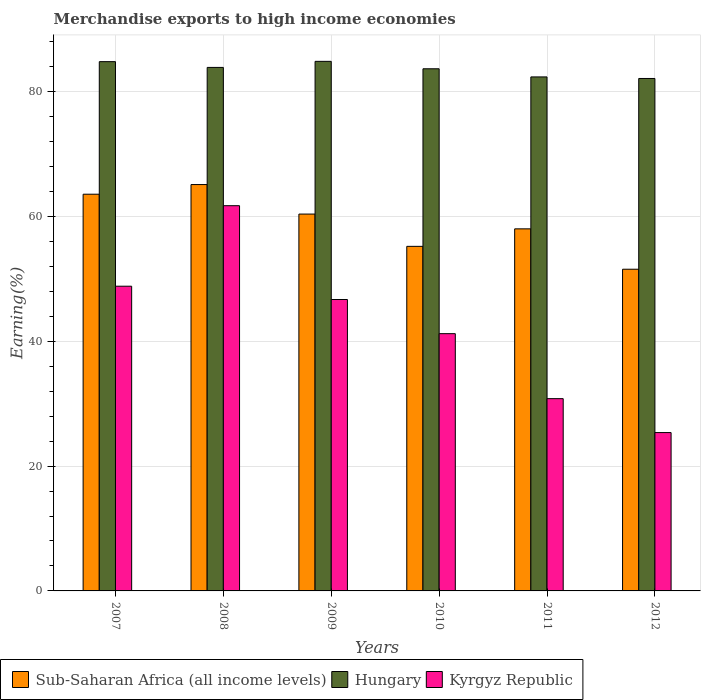How many different coloured bars are there?
Provide a short and direct response. 3. Are the number of bars on each tick of the X-axis equal?
Offer a very short reply. Yes. What is the percentage of amount earned from merchandise exports in Hungary in 2010?
Make the answer very short. 83.67. Across all years, what is the maximum percentage of amount earned from merchandise exports in Hungary?
Your response must be concise. 84.86. Across all years, what is the minimum percentage of amount earned from merchandise exports in Sub-Saharan Africa (all income levels)?
Your response must be concise. 51.55. What is the total percentage of amount earned from merchandise exports in Kyrgyz Republic in the graph?
Offer a very short reply. 254.66. What is the difference between the percentage of amount earned from merchandise exports in Kyrgyz Republic in 2008 and that in 2010?
Your response must be concise. 20.51. What is the difference between the percentage of amount earned from merchandise exports in Kyrgyz Republic in 2010 and the percentage of amount earned from merchandise exports in Hungary in 2009?
Your answer should be very brief. -43.64. What is the average percentage of amount earned from merchandise exports in Sub-Saharan Africa (all income levels) per year?
Ensure brevity in your answer.  58.98. In the year 2012, what is the difference between the percentage of amount earned from merchandise exports in Kyrgyz Republic and percentage of amount earned from merchandise exports in Sub-Saharan Africa (all income levels)?
Offer a very short reply. -26.18. What is the ratio of the percentage of amount earned from merchandise exports in Hungary in 2008 to that in 2011?
Provide a short and direct response. 1.02. Is the percentage of amount earned from merchandise exports in Sub-Saharan Africa (all income levels) in 2008 less than that in 2012?
Provide a short and direct response. No. What is the difference between the highest and the second highest percentage of amount earned from merchandise exports in Sub-Saharan Africa (all income levels)?
Keep it short and to the point. 1.55. What is the difference between the highest and the lowest percentage of amount earned from merchandise exports in Sub-Saharan Africa (all income levels)?
Your answer should be very brief. 13.57. In how many years, is the percentage of amount earned from merchandise exports in Hungary greater than the average percentage of amount earned from merchandise exports in Hungary taken over all years?
Keep it short and to the point. 4. What does the 1st bar from the left in 2008 represents?
Ensure brevity in your answer.  Sub-Saharan Africa (all income levels). What does the 2nd bar from the right in 2012 represents?
Provide a succinct answer. Hungary. What is the difference between two consecutive major ticks on the Y-axis?
Offer a very short reply. 20. Are the values on the major ticks of Y-axis written in scientific E-notation?
Your response must be concise. No. Where does the legend appear in the graph?
Your answer should be very brief. Bottom left. How are the legend labels stacked?
Offer a very short reply. Horizontal. What is the title of the graph?
Give a very brief answer. Merchandise exports to high income economies. Does "Suriname" appear as one of the legend labels in the graph?
Provide a succinct answer. No. What is the label or title of the Y-axis?
Your response must be concise. Earning(%). What is the Earning(%) of Sub-Saharan Africa (all income levels) in 2007?
Ensure brevity in your answer.  63.57. What is the Earning(%) of Hungary in 2007?
Make the answer very short. 84.81. What is the Earning(%) of Kyrgyz Republic in 2007?
Offer a very short reply. 48.83. What is the Earning(%) in Sub-Saharan Africa (all income levels) in 2008?
Offer a very short reply. 65.12. What is the Earning(%) in Hungary in 2008?
Provide a short and direct response. 83.89. What is the Earning(%) in Kyrgyz Republic in 2008?
Your answer should be very brief. 61.73. What is the Earning(%) of Sub-Saharan Africa (all income levels) in 2009?
Make the answer very short. 60.39. What is the Earning(%) of Hungary in 2009?
Keep it short and to the point. 84.86. What is the Earning(%) in Kyrgyz Republic in 2009?
Your answer should be compact. 46.7. What is the Earning(%) of Sub-Saharan Africa (all income levels) in 2010?
Give a very brief answer. 55.21. What is the Earning(%) in Hungary in 2010?
Give a very brief answer. 83.67. What is the Earning(%) of Kyrgyz Republic in 2010?
Your answer should be compact. 41.22. What is the Earning(%) of Sub-Saharan Africa (all income levels) in 2011?
Make the answer very short. 58.02. What is the Earning(%) in Hungary in 2011?
Keep it short and to the point. 82.36. What is the Earning(%) in Kyrgyz Republic in 2011?
Your response must be concise. 30.81. What is the Earning(%) in Sub-Saharan Africa (all income levels) in 2012?
Ensure brevity in your answer.  51.55. What is the Earning(%) in Hungary in 2012?
Your response must be concise. 82.12. What is the Earning(%) in Kyrgyz Republic in 2012?
Keep it short and to the point. 25.37. Across all years, what is the maximum Earning(%) in Sub-Saharan Africa (all income levels)?
Your answer should be very brief. 65.12. Across all years, what is the maximum Earning(%) of Hungary?
Provide a succinct answer. 84.86. Across all years, what is the maximum Earning(%) in Kyrgyz Republic?
Provide a short and direct response. 61.73. Across all years, what is the minimum Earning(%) of Sub-Saharan Africa (all income levels)?
Keep it short and to the point. 51.55. Across all years, what is the minimum Earning(%) in Hungary?
Give a very brief answer. 82.12. Across all years, what is the minimum Earning(%) in Kyrgyz Republic?
Your answer should be very brief. 25.37. What is the total Earning(%) in Sub-Saharan Africa (all income levels) in the graph?
Give a very brief answer. 353.86. What is the total Earning(%) of Hungary in the graph?
Keep it short and to the point. 501.7. What is the total Earning(%) in Kyrgyz Republic in the graph?
Provide a short and direct response. 254.66. What is the difference between the Earning(%) of Sub-Saharan Africa (all income levels) in 2007 and that in 2008?
Provide a succinct answer. -1.55. What is the difference between the Earning(%) in Hungary in 2007 and that in 2008?
Your response must be concise. 0.93. What is the difference between the Earning(%) in Kyrgyz Republic in 2007 and that in 2008?
Your answer should be compact. -12.9. What is the difference between the Earning(%) of Sub-Saharan Africa (all income levels) in 2007 and that in 2009?
Your answer should be compact. 3.18. What is the difference between the Earning(%) in Hungary in 2007 and that in 2009?
Offer a terse response. -0.05. What is the difference between the Earning(%) of Kyrgyz Republic in 2007 and that in 2009?
Your answer should be compact. 2.13. What is the difference between the Earning(%) in Sub-Saharan Africa (all income levels) in 2007 and that in 2010?
Your answer should be compact. 8.36. What is the difference between the Earning(%) of Hungary in 2007 and that in 2010?
Your answer should be compact. 1.14. What is the difference between the Earning(%) in Kyrgyz Republic in 2007 and that in 2010?
Offer a terse response. 7.6. What is the difference between the Earning(%) in Sub-Saharan Africa (all income levels) in 2007 and that in 2011?
Provide a succinct answer. 5.55. What is the difference between the Earning(%) in Hungary in 2007 and that in 2011?
Keep it short and to the point. 2.45. What is the difference between the Earning(%) in Kyrgyz Republic in 2007 and that in 2011?
Offer a terse response. 18.02. What is the difference between the Earning(%) in Sub-Saharan Africa (all income levels) in 2007 and that in 2012?
Provide a short and direct response. 12.02. What is the difference between the Earning(%) of Hungary in 2007 and that in 2012?
Make the answer very short. 2.7. What is the difference between the Earning(%) in Kyrgyz Republic in 2007 and that in 2012?
Provide a succinct answer. 23.45. What is the difference between the Earning(%) of Sub-Saharan Africa (all income levels) in 2008 and that in 2009?
Offer a terse response. 4.73. What is the difference between the Earning(%) of Hungary in 2008 and that in 2009?
Provide a short and direct response. -0.97. What is the difference between the Earning(%) of Kyrgyz Republic in 2008 and that in 2009?
Make the answer very short. 15.03. What is the difference between the Earning(%) of Sub-Saharan Africa (all income levels) in 2008 and that in 2010?
Your answer should be very brief. 9.9. What is the difference between the Earning(%) in Hungary in 2008 and that in 2010?
Offer a terse response. 0.22. What is the difference between the Earning(%) in Kyrgyz Republic in 2008 and that in 2010?
Offer a terse response. 20.51. What is the difference between the Earning(%) of Sub-Saharan Africa (all income levels) in 2008 and that in 2011?
Your answer should be very brief. 7.1. What is the difference between the Earning(%) of Hungary in 2008 and that in 2011?
Your answer should be very brief. 1.52. What is the difference between the Earning(%) of Kyrgyz Republic in 2008 and that in 2011?
Your answer should be very brief. 30.92. What is the difference between the Earning(%) in Sub-Saharan Africa (all income levels) in 2008 and that in 2012?
Give a very brief answer. 13.57. What is the difference between the Earning(%) of Hungary in 2008 and that in 2012?
Provide a short and direct response. 1.77. What is the difference between the Earning(%) in Kyrgyz Republic in 2008 and that in 2012?
Keep it short and to the point. 36.35. What is the difference between the Earning(%) in Sub-Saharan Africa (all income levels) in 2009 and that in 2010?
Provide a succinct answer. 5.17. What is the difference between the Earning(%) of Hungary in 2009 and that in 2010?
Offer a very short reply. 1.19. What is the difference between the Earning(%) in Kyrgyz Republic in 2009 and that in 2010?
Ensure brevity in your answer.  5.47. What is the difference between the Earning(%) of Sub-Saharan Africa (all income levels) in 2009 and that in 2011?
Offer a terse response. 2.37. What is the difference between the Earning(%) of Hungary in 2009 and that in 2011?
Give a very brief answer. 2.49. What is the difference between the Earning(%) of Kyrgyz Republic in 2009 and that in 2011?
Keep it short and to the point. 15.89. What is the difference between the Earning(%) of Sub-Saharan Africa (all income levels) in 2009 and that in 2012?
Offer a very short reply. 8.84. What is the difference between the Earning(%) in Hungary in 2009 and that in 2012?
Your answer should be compact. 2.74. What is the difference between the Earning(%) in Kyrgyz Republic in 2009 and that in 2012?
Give a very brief answer. 21.32. What is the difference between the Earning(%) in Sub-Saharan Africa (all income levels) in 2010 and that in 2011?
Keep it short and to the point. -2.81. What is the difference between the Earning(%) of Hungary in 2010 and that in 2011?
Make the answer very short. 1.3. What is the difference between the Earning(%) of Kyrgyz Republic in 2010 and that in 2011?
Give a very brief answer. 10.41. What is the difference between the Earning(%) in Sub-Saharan Africa (all income levels) in 2010 and that in 2012?
Your answer should be very brief. 3.66. What is the difference between the Earning(%) of Hungary in 2010 and that in 2012?
Give a very brief answer. 1.55. What is the difference between the Earning(%) in Kyrgyz Republic in 2010 and that in 2012?
Offer a terse response. 15.85. What is the difference between the Earning(%) of Sub-Saharan Africa (all income levels) in 2011 and that in 2012?
Offer a terse response. 6.47. What is the difference between the Earning(%) in Hungary in 2011 and that in 2012?
Your answer should be compact. 0.25. What is the difference between the Earning(%) in Kyrgyz Republic in 2011 and that in 2012?
Offer a very short reply. 5.44. What is the difference between the Earning(%) in Sub-Saharan Africa (all income levels) in 2007 and the Earning(%) in Hungary in 2008?
Offer a terse response. -20.32. What is the difference between the Earning(%) of Sub-Saharan Africa (all income levels) in 2007 and the Earning(%) of Kyrgyz Republic in 2008?
Provide a succinct answer. 1.84. What is the difference between the Earning(%) in Hungary in 2007 and the Earning(%) in Kyrgyz Republic in 2008?
Offer a terse response. 23.08. What is the difference between the Earning(%) of Sub-Saharan Africa (all income levels) in 2007 and the Earning(%) of Hungary in 2009?
Provide a succinct answer. -21.29. What is the difference between the Earning(%) of Sub-Saharan Africa (all income levels) in 2007 and the Earning(%) of Kyrgyz Republic in 2009?
Offer a terse response. 16.87. What is the difference between the Earning(%) in Hungary in 2007 and the Earning(%) in Kyrgyz Republic in 2009?
Ensure brevity in your answer.  38.12. What is the difference between the Earning(%) in Sub-Saharan Africa (all income levels) in 2007 and the Earning(%) in Hungary in 2010?
Provide a succinct answer. -20.1. What is the difference between the Earning(%) of Sub-Saharan Africa (all income levels) in 2007 and the Earning(%) of Kyrgyz Republic in 2010?
Offer a terse response. 22.35. What is the difference between the Earning(%) of Hungary in 2007 and the Earning(%) of Kyrgyz Republic in 2010?
Provide a succinct answer. 43.59. What is the difference between the Earning(%) of Sub-Saharan Africa (all income levels) in 2007 and the Earning(%) of Hungary in 2011?
Your answer should be very brief. -18.79. What is the difference between the Earning(%) of Sub-Saharan Africa (all income levels) in 2007 and the Earning(%) of Kyrgyz Republic in 2011?
Provide a succinct answer. 32.76. What is the difference between the Earning(%) of Hungary in 2007 and the Earning(%) of Kyrgyz Republic in 2011?
Your answer should be compact. 54. What is the difference between the Earning(%) in Sub-Saharan Africa (all income levels) in 2007 and the Earning(%) in Hungary in 2012?
Ensure brevity in your answer.  -18.55. What is the difference between the Earning(%) of Sub-Saharan Africa (all income levels) in 2007 and the Earning(%) of Kyrgyz Republic in 2012?
Provide a succinct answer. 38.2. What is the difference between the Earning(%) of Hungary in 2007 and the Earning(%) of Kyrgyz Republic in 2012?
Your response must be concise. 59.44. What is the difference between the Earning(%) in Sub-Saharan Africa (all income levels) in 2008 and the Earning(%) in Hungary in 2009?
Your answer should be very brief. -19.74. What is the difference between the Earning(%) in Sub-Saharan Africa (all income levels) in 2008 and the Earning(%) in Kyrgyz Republic in 2009?
Make the answer very short. 18.42. What is the difference between the Earning(%) in Hungary in 2008 and the Earning(%) in Kyrgyz Republic in 2009?
Provide a short and direct response. 37.19. What is the difference between the Earning(%) of Sub-Saharan Africa (all income levels) in 2008 and the Earning(%) of Hungary in 2010?
Your answer should be very brief. -18.55. What is the difference between the Earning(%) in Sub-Saharan Africa (all income levels) in 2008 and the Earning(%) in Kyrgyz Republic in 2010?
Offer a very short reply. 23.89. What is the difference between the Earning(%) in Hungary in 2008 and the Earning(%) in Kyrgyz Republic in 2010?
Offer a very short reply. 42.66. What is the difference between the Earning(%) in Sub-Saharan Africa (all income levels) in 2008 and the Earning(%) in Hungary in 2011?
Your answer should be compact. -17.25. What is the difference between the Earning(%) in Sub-Saharan Africa (all income levels) in 2008 and the Earning(%) in Kyrgyz Republic in 2011?
Ensure brevity in your answer.  34.31. What is the difference between the Earning(%) in Hungary in 2008 and the Earning(%) in Kyrgyz Republic in 2011?
Make the answer very short. 53.08. What is the difference between the Earning(%) of Sub-Saharan Africa (all income levels) in 2008 and the Earning(%) of Hungary in 2012?
Make the answer very short. -17. What is the difference between the Earning(%) of Sub-Saharan Africa (all income levels) in 2008 and the Earning(%) of Kyrgyz Republic in 2012?
Provide a short and direct response. 39.74. What is the difference between the Earning(%) of Hungary in 2008 and the Earning(%) of Kyrgyz Republic in 2012?
Your response must be concise. 58.51. What is the difference between the Earning(%) in Sub-Saharan Africa (all income levels) in 2009 and the Earning(%) in Hungary in 2010?
Offer a very short reply. -23.28. What is the difference between the Earning(%) of Sub-Saharan Africa (all income levels) in 2009 and the Earning(%) of Kyrgyz Republic in 2010?
Provide a succinct answer. 19.16. What is the difference between the Earning(%) in Hungary in 2009 and the Earning(%) in Kyrgyz Republic in 2010?
Give a very brief answer. 43.64. What is the difference between the Earning(%) in Sub-Saharan Africa (all income levels) in 2009 and the Earning(%) in Hungary in 2011?
Your response must be concise. -21.98. What is the difference between the Earning(%) of Sub-Saharan Africa (all income levels) in 2009 and the Earning(%) of Kyrgyz Republic in 2011?
Ensure brevity in your answer.  29.58. What is the difference between the Earning(%) of Hungary in 2009 and the Earning(%) of Kyrgyz Republic in 2011?
Ensure brevity in your answer.  54.05. What is the difference between the Earning(%) of Sub-Saharan Africa (all income levels) in 2009 and the Earning(%) of Hungary in 2012?
Give a very brief answer. -21.73. What is the difference between the Earning(%) of Sub-Saharan Africa (all income levels) in 2009 and the Earning(%) of Kyrgyz Republic in 2012?
Keep it short and to the point. 35.01. What is the difference between the Earning(%) of Hungary in 2009 and the Earning(%) of Kyrgyz Republic in 2012?
Keep it short and to the point. 59.48. What is the difference between the Earning(%) of Sub-Saharan Africa (all income levels) in 2010 and the Earning(%) of Hungary in 2011?
Your response must be concise. -27.15. What is the difference between the Earning(%) in Sub-Saharan Africa (all income levels) in 2010 and the Earning(%) in Kyrgyz Republic in 2011?
Your response must be concise. 24.4. What is the difference between the Earning(%) in Hungary in 2010 and the Earning(%) in Kyrgyz Republic in 2011?
Offer a very short reply. 52.86. What is the difference between the Earning(%) of Sub-Saharan Africa (all income levels) in 2010 and the Earning(%) of Hungary in 2012?
Ensure brevity in your answer.  -26.9. What is the difference between the Earning(%) of Sub-Saharan Africa (all income levels) in 2010 and the Earning(%) of Kyrgyz Republic in 2012?
Your response must be concise. 29.84. What is the difference between the Earning(%) in Hungary in 2010 and the Earning(%) in Kyrgyz Republic in 2012?
Offer a terse response. 58.3. What is the difference between the Earning(%) in Sub-Saharan Africa (all income levels) in 2011 and the Earning(%) in Hungary in 2012?
Provide a succinct answer. -24.1. What is the difference between the Earning(%) of Sub-Saharan Africa (all income levels) in 2011 and the Earning(%) of Kyrgyz Republic in 2012?
Give a very brief answer. 32.65. What is the difference between the Earning(%) of Hungary in 2011 and the Earning(%) of Kyrgyz Republic in 2012?
Offer a terse response. 56.99. What is the average Earning(%) in Sub-Saharan Africa (all income levels) per year?
Your response must be concise. 58.98. What is the average Earning(%) of Hungary per year?
Ensure brevity in your answer.  83.62. What is the average Earning(%) in Kyrgyz Republic per year?
Ensure brevity in your answer.  42.44. In the year 2007, what is the difference between the Earning(%) of Sub-Saharan Africa (all income levels) and Earning(%) of Hungary?
Give a very brief answer. -21.24. In the year 2007, what is the difference between the Earning(%) of Sub-Saharan Africa (all income levels) and Earning(%) of Kyrgyz Republic?
Your response must be concise. 14.74. In the year 2007, what is the difference between the Earning(%) of Hungary and Earning(%) of Kyrgyz Republic?
Give a very brief answer. 35.99. In the year 2008, what is the difference between the Earning(%) of Sub-Saharan Africa (all income levels) and Earning(%) of Hungary?
Offer a very short reply. -18.77. In the year 2008, what is the difference between the Earning(%) in Sub-Saharan Africa (all income levels) and Earning(%) in Kyrgyz Republic?
Your answer should be compact. 3.39. In the year 2008, what is the difference between the Earning(%) of Hungary and Earning(%) of Kyrgyz Republic?
Provide a succinct answer. 22.16. In the year 2009, what is the difference between the Earning(%) of Sub-Saharan Africa (all income levels) and Earning(%) of Hungary?
Make the answer very short. -24.47. In the year 2009, what is the difference between the Earning(%) of Sub-Saharan Africa (all income levels) and Earning(%) of Kyrgyz Republic?
Offer a very short reply. 13.69. In the year 2009, what is the difference between the Earning(%) of Hungary and Earning(%) of Kyrgyz Republic?
Your response must be concise. 38.16. In the year 2010, what is the difference between the Earning(%) of Sub-Saharan Africa (all income levels) and Earning(%) of Hungary?
Provide a succinct answer. -28.45. In the year 2010, what is the difference between the Earning(%) in Sub-Saharan Africa (all income levels) and Earning(%) in Kyrgyz Republic?
Make the answer very short. 13.99. In the year 2010, what is the difference between the Earning(%) of Hungary and Earning(%) of Kyrgyz Republic?
Your answer should be compact. 42.45. In the year 2011, what is the difference between the Earning(%) in Sub-Saharan Africa (all income levels) and Earning(%) in Hungary?
Provide a short and direct response. -24.34. In the year 2011, what is the difference between the Earning(%) in Sub-Saharan Africa (all income levels) and Earning(%) in Kyrgyz Republic?
Keep it short and to the point. 27.21. In the year 2011, what is the difference between the Earning(%) in Hungary and Earning(%) in Kyrgyz Republic?
Your answer should be very brief. 51.55. In the year 2012, what is the difference between the Earning(%) of Sub-Saharan Africa (all income levels) and Earning(%) of Hungary?
Offer a very short reply. -30.57. In the year 2012, what is the difference between the Earning(%) of Sub-Saharan Africa (all income levels) and Earning(%) of Kyrgyz Republic?
Offer a terse response. 26.18. In the year 2012, what is the difference between the Earning(%) of Hungary and Earning(%) of Kyrgyz Republic?
Provide a succinct answer. 56.74. What is the ratio of the Earning(%) of Sub-Saharan Africa (all income levels) in 2007 to that in 2008?
Offer a terse response. 0.98. What is the ratio of the Earning(%) in Hungary in 2007 to that in 2008?
Give a very brief answer. 1.01. What is the ratio of the Earning(%) of Kyrgyz Republic in 2007 to that in 2008?
Give a very brief answer. 0.79. What is the ratio of the Earning(%) in Sub-Saharan Africa (all income levels) in 2007 to that in 2009?
Offer a terse response. 1.05. What is the ratio of the Earning(%) of Hungary in 2007 to that in 2009?
Your answer should be compact. 1. What is the ratio of the Earning(%) in Kyrgyz Republic in 2007 to that in 2009?
Your response must be concise. 1.05. What is the ratio of the Earning(%) in Sub-Saharan Africa (all income levels) in 2007 to that in 2010?
Ensure brevity in your answer.  1.15. What is the ratio of the Earning(%) in Hungary in 2007 to that in 2010?
Give a very brief answer. 1.01. What is the ratio of the Earning(%) of Kyrgyz Republic in 2007 to that in 2010?
Provide a succinct answer. 1.18. What is the ratio of the Earning(%) of Sub-Saharan Africa (all income levels) in 2007 to that in 2011?
Your response must be concise. 1.1. What is the ratio of the Earning(%) of Hungary in 2007 to that in 2011?
Your answer should be compact. 1.03. What is the ratio of the Earning(%) of Kyrgyz Republic in 2007 to that in 2011?
Offer a very short reply. 1.58. What is the ratio of the Earning(%) of Sub-Saharan Africa (all income levels) in 2007 to that in 2012?
Offer a very short reply. 1.23. What is the ratio of the Earning(%) in Hungary in 2007 to that in 2012?
Offer a very short reply. 1.03. What is the ratio of the Earning(%) of Kyrgyz Republic in 2007 to that in 2012?
Keep it short and to the point. 1.92. What is the ratio of the Earning(%) of Sub-Saharan Africa (all income levels) in 2008 to that in 2009?
Offer a terse response. 1.08. What is the ratio of the Earning(%) in Hungary in 2008 to that in 2009?
Provide a succinct answer. 0.99. What is the ratio of the Earning(%) of Kyrgyz Republic in 2008 to that in 2009?
Offer a terse response. 1.32. What is the ratio of the Earning(%) in Sub-Saharan Africa (all income levels) in 2008 to that in 2010?
Offer a terse response. 1.18. What is the ratio of the Earning(%) of Hungary in 2008 to that in 2010?
Ensure brevity in your answer.  1. What is the ratio of the Earning(%) in Kyrgyz Republic in 2008 to that in 2010?
Provide a succinct answer. 1.5. What is the ratio of the Earning(%) of Sub-Saharan Africa (all income levels) in 2008 to that in 2011?
Your answer should be compact. 1.12. What is the ratio of the Earning(%) in Hungary in 2008 to that in 2011?
Your response must be concise. 1.02. What is the ratio of the Earning(%) of Kyrgyz Republic in 2008 to that in 2011?
Give a very brief answer. 2. What is the ratio of the Earning(%) of Sub-Saharan Africa (all income levels) in 2008 to that in 2012?
Make the answer very short. 1.26. What is the ratio of the Earning(%) of Hungary in 2008 to that in 2012?
Ensure brevity in your answer.  1.02. What is the ratio of the Earning(%) of Kyrgyz Republic in 2008 to that in 2012?
Give a very brief answer. 2.43. What is the ratio of the Earning(%) in Sub-Saharan Africa (all income levels) in 2009 to that in 2010?
Ensure brevity in your answer.  1.09. What is the ratio of the Earning(%) of Hungary in 2009 to that in 2010?
Your response must be concise. 1.01. What is the ratio of the Earning(%) of Kyrgyz Republic in 2009 to that in 2010?
Provide a succinct answer. 1.13. What is the ratio of the Earning(%) in Sub-Saharan Africa (all income levels) in 2009 to that in 2011?
Your answer should be compact. 1.04. What is the ratio of the Earning(%) of Hungary in 2009 to that in 2011?
Offer a very short reply. 1.03. What is the ratio of the Earning(%) of Kyrgyz Republic in 2009 to that in 2011?
Your answer should be compact. 1.52. What is the ratio of the Earning(%) of Sub-Saharan Africa (all income levels) in 2009 to that in 2012?
Your answer should be very brief. 1.17. What is the ratio of the Earning(%) of Hungary in 2009 to that in 2012?
Your answer should be compact. 1.03. What is the ratio of the Earning(%) in Kyrgyz Republic in 2009 to that in 2012?
Offer a terse response. 1.84. What is the ratio of the Earning(%) in Sub-Saharan Africa (all income levels) in 2010 to that in 2011?
Ensure brevity in your answer.  0.95. What is the ratio of the Earning(%) in Hungary in 2010 to that in 2011?
Give a very brief answer. 1.02. What is the ratio of the Earning(%) of Kyrgyz Republic in 2010 to that in 2011?
Make the answer very short. 1.34. What is the ratio of the Earning(%) of Sub-Saharan Africa (all income levels) in 2010 to that in 2012?
Offer a terse response. 1.07. What is the ratio of the Earning(%) of Hungary in 2010 to that in 2012?
Provide a short and direct response. 1.02. What is the ratio of the Earning(%) of Kyrgyz Republic in 2010 to that in 2012?
Ensure brevity in your answer.  1.62. What is the ratio of the Earning(%) in Sub-Saharan Africa (all income levels) in 2011 to that in 2012?
Offer a terse response. 1.13. What is the ratio of the Earning(%) of Hungary in 2011 to that in 2012?
Offer a terse response. 1. What is the ratio of the Earning(%) in Kyrgyz Republic in 2011 to that in 2012?
Provide a succinct answer. 1.21. What is the difference between the highest and the second highest Earning(%) of Sub-Saharan Africa (all income levels)?
Give a very brief answer. 1.55. What is the difference between the highest and the second highest Earning(%) of Hungary?
Give a very brief answer. 0.05. What is the difference between the highest and the second highest Earning(%) in Kyrgyz Republic?
Give a very brief answer. 12.9. What is the difference between the highest and the lowest Earning(%) in Sub-Saharan Africa (all income levels)?
Make the answer very short. 13.57. What is the difference between the highest and the lowest Earning(%) in Hungary?
Keep it short and to the point. 2.74. What is the difference between the highest and the lowest Earning(%) in Kyrgyz Republic?
Offer a terse response. 36.35. 